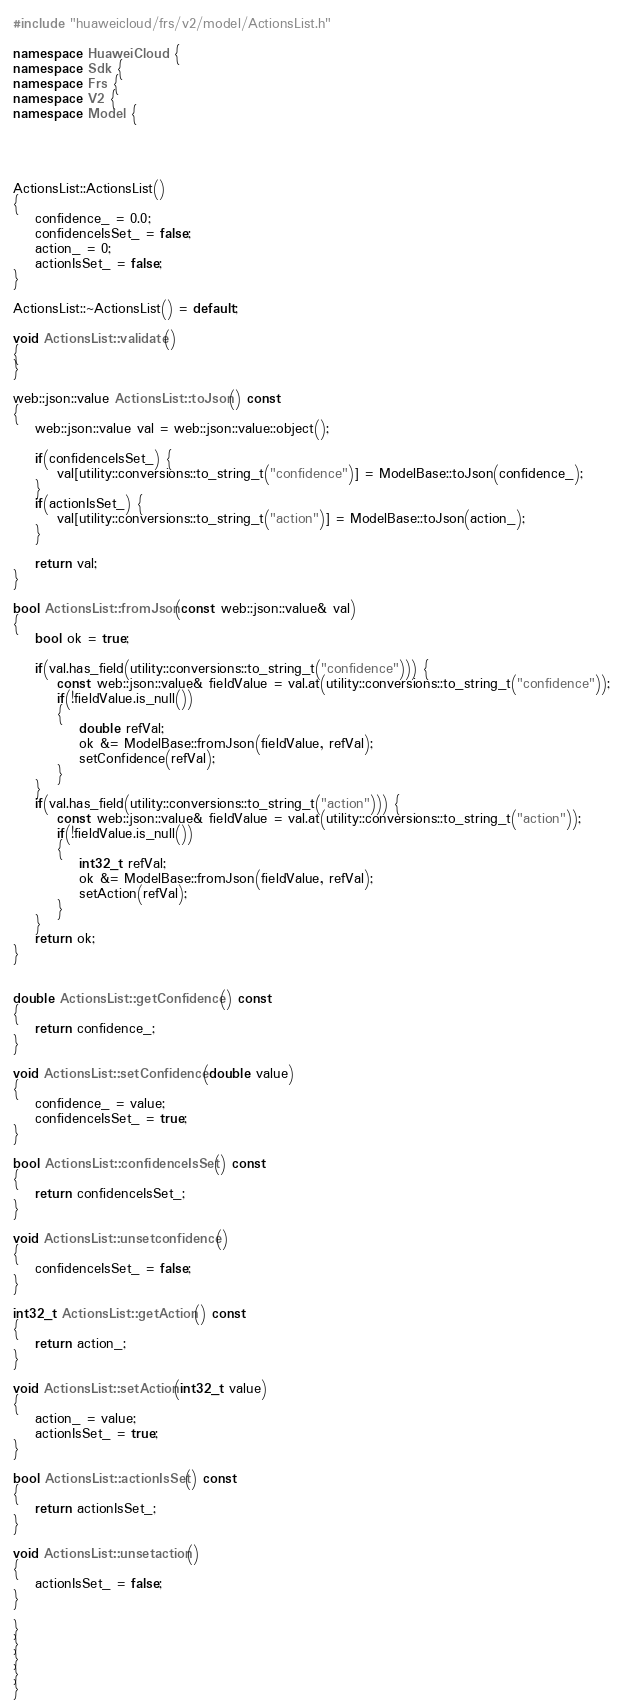<code> <loc_0><loc_0><loc_500><loc_500><_C++_>

#include "huaweicloud/frs/v2/model/ActionsList.h"

namespace HuaweiCloud {
namespace Sdk {
namespace Frs {
namespace V2 {
namespace Model {




ActionsList::ActionsList()
{
    confidence_ = 0.0;
    confidenceIsSet_ = false;
    action_ = 0;
    actionIsSet_ = false;
}

ActionsList::~ActionsList() = default;

void ActionsList::validate()
{
}

web::json::value ActionsList::toJson() const
{
    web::json::value val = web::json::value::object();

    if(confidenceIsSet_) {
        val[utility::conversions::to_string_t("confidence")] = ModelBase::toJson(confidence_);
    }
    if(actionIsSet_) {
        val[utility::conversions::to_string_t("action")] = ModelBase::toJson(action_);
    }

    return val;
}

bool ActionsList::fromJson(const web::json::value& val)
{
    bool ok = true;
    
    if(val.has_field(utility::conversions::to_string_t("confidence"))) {
        const web::json::value& fieldValue = val.at(utility::conversions::to_string_t("confidence"));
        if(!fieldValue.is_null())
        {
            double refVal;
            ok &= ModelBase::fromJson(fieldValue, refVal);
            setConfidence(refVal);
        }
    }
    if(val.has_field(utility::conversions::to_string_t("action"))) {
        const web::json::value& fieldValue = val.at(utility::conversions::to_string_t("action"));
        if(!fieldValue.is_null())
        {
            int32_t refVal;
            ok &= ModelBase::fromJson(fieldValue, refVal);
            setAction(refVal);
        }
    }
    return ok;
}


double ActionsList::getConfidence() const
{
    return confidence_;
}

void ActionsList::setConfidence(double value)
{
    confidence_ = value;
    confidenceIsSet_ = true;
}

bool ActionsList::confidenceIsSet() const
{
    return confidenceIsSet_;
}

void ActionsList::unsetconfidence()
{
    confidenceIsSet_ = false;
}

int32_t ActionsList::getAction() const
{
    return action_;
}

void ActionsList::setAction(int32_t value)
{
    action_ = value;
    actionIsSet_ = true;
}

bool ActionsList::actionIsSet() const
{
    return actionIsSet_;
}

void ActionsList::unsetaction()
{
    actionIsSet_ = false;
}

}
}
}
}
}


</code> 